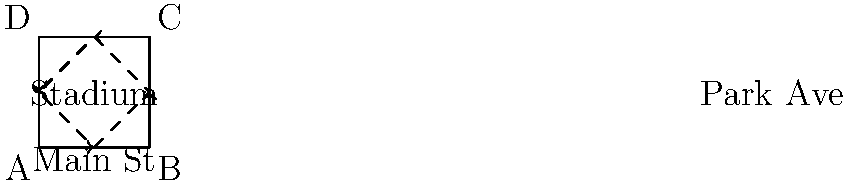As a civil engineer tasked with optimizing traffic flow around the Richmond Tigers' new stadium complex, you're considering a diamond interchange design. If the peak traffic flow during game days is 2000 vehicles per hour (vph) entering from each direction (A, B, C, and D), and each internal road of the diamond (E-F, F-G, G-H, and H-E) can handle 1500 vph, what is the maximum number of vehicles per hour that can be efficiently managed by this system without causing congestion? Let's approach this step-by-step:

1. Understand the layout:
   - We have four entry points (A, B, C, D) with 2000 vph each.
   - The diamond interchange has four internal roads, each handling 1500 vph.

2. Calculate total incoming traffic:
   $$ \text{Total incoming} = 4 \times 2000 = 8000 \text{ vph} $$

3. Analyze the diamond capacity:
   - Each internal road can handle 1500 vph.
   - There are four internal roads.
   - Total capacity of the diamond: $4 \times 1500 = 6000 \text{ vph}$

4. Compare incoming traffic to diamond capacity:
   - The diamond can only handle 6000 vph, but 8000 vph are trying to enter.
   - This means 2000 vph will face congestion.

5. Calculate the maximum efficiently managed traffic:
   - The system can efficiently manage the capacity of the diamond.
   $$ \text{Maximum efficient flow} = 6000 \text{ vph} $$

This solution ensures smooth flow within the diamond interchange, preventing internal congestion while maximizing throughput.
Answer: 6000 vehicles per hour 